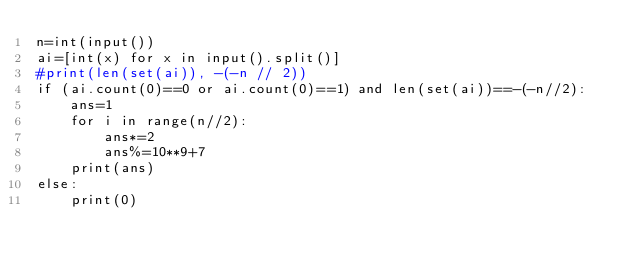<code> <loc_0><loc_0><loc_500><loc_500><_Python_>n=int(input())
ai=[int(x) for x in input().split()]
#print(len(set(ai)), -(-n // 2))
if (ai.count(0)==0 or ai.count(0)==1) and len(set(ai))==-(-n//2):
    ans=1
    for i in range(n//2):
        ans*=2
        ans%=10**9+7
    print(ans)
else:
    print(0)</code> 